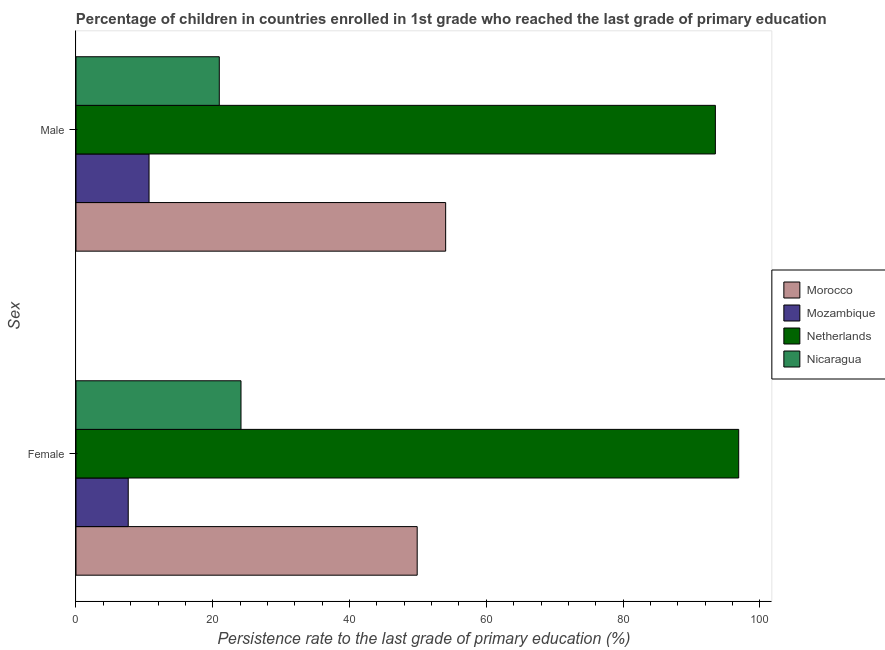How many different coloured bars are there?
Make the answer very short. 4. How many groups of bars are there?
Provide a succinct answer. 2. Are the number of bars on each tick of the Y-axis equal?
Provide a short and direct response. Yes. How many bars are there on the 2nd tick from the bottom?
Give a very brief answer. 4. What is the label of the 1st group of bars from the top?
Provide a succinct answer. Male. What is the persistence rate of female students in Mozambique?
Keep it short and to the point. 7.64. Across all countries, what is the maximum persistence rate of female students?
Give a very brief answer. 96.9. Across all countries, what is the minimum persistence rate of female students?
Keep it short and to the point. 7.64. In which country was the persistence rate of male students minimum?
Keep it short and to the point. Mozambique. What is the total persistence rate of female students in the graph?
Offer a very short reply. 178.56. What is the difference between the persistence rate of male students in Nicaragua and that in Morocco?
Your answer should be compact. -33.1. What is the difference between the persistence rate of male students in Mozambique and the persistence rate of female students in Netherlands?
Make the answer very short. -86.22. What is the average persistence rate of female students per country?
Offer a terse response. 44.64. What is the difference between the persistence rate of female students and persistence rate of male students in Morocco?
Offer a very short reply. -4.16. In how many countries, is the persistence rate of female students greater than 36 %?
Give a very brief answer. 2. What is the ratio of the persistence rate of female students in Netherlands to that in Morocco?
Your response must be concise. 1.94. In how many countries, is the persistence rate of female students greater than the average persistence rate of female students taken over all countries?
Keep it short and to the point. 2. What does the 1st bar from the top in Female represents?
Your answer should be very brief. Nicaragua. What does the 4th bar from the bottom in Female represents?
Provide a succinct answer. Nicaragua. How many bars are there?
Your answer should be compact. 8. Are the values on the major ticks of X-axis written in scientific E-notation?
Ensure brevity in your answer.  No. Does the graph contain any zero values?
Give a very brief answer. No. How are the legend labels stacked?
Offer a very short reply. Vertical. What is the title of the graph?
Offer a terse response. Percentage of children in countries enrolled in 1st grade who reached the last grade of primary education. What is the label or title of the X-axis?
Your response must be concise. Persistence rate to the last grade of primary education (%). What is the label or title of the Y-axis?
Provide a succinct answer. Sex. What is the Persistence rate to the last grade of primary education (%) of Morocco in Female?
Your response must be concise. 49.89. What is the Persistence rate to the last grade of primary education (%) in Mozambique in Female?
Keep it short and to the point. 7.64. What is the Persistence rate to the last grade of primary education (%) of Netherlands in Female?
Your answer should be compact. 96.9. What is the Persistence rate to the last grade of primary education (%) of Nicaragua in Female?
Your answer should be compact. 24.13. What is the Persistence rate to the last grade of primary education (%) of Morocco in Male?
Offer a very short reply. 54.05. What is the Persistence rate to the last grade of primary education (%) of Mozambique in Male?
Ensure brevity in your answer.  10.68. What is the Persistence rate to the last grade of primary education (%) in Netherlands in Male?
Provide a short and direct response. 93.49. What is the Persistence rate to the last grade of primary education (%) of Nicaragua in Male?
Keep it short and to the point. 20.95. Across all Sex, what is the maximum Persistence rate to the last grade of primary education (%) in Morocco?
Give a very brief answer. 54.05. Across all Sex, what is the maximum Persistence rate to the last grade of primary education (%) of Mozambique?
Make the answer very short. 10.68. Across all Sex, what is the maximum Persistence rate to the last grade of primary education (%) of Netherlands?
Give a very brief answer. 96.9. Across all Sex, what is the maximum Persistence rate to the last grade of primary education (%) in Nicaragua?
Provide a succinct answer. 24.13. Across all Sex, what is the minimum Persistence rate to the last grade of primary education (%) in Morocco?
Offer a terse response. 49.89. Across all Sex, what is the minimum Persistence rate to the last grade of primary education (%) in Mozambique?
Offer a very short reply. 7.64. Across all Sex, what is the minimum Persistence rate to the last grade of primary education (%) of Netherlands?
Offer a very short reply. 93.49. Across all Sex, what is the minimum Persistence rate to the last grade of primary education (%) of Nicaragua?
Offer a terse response. 20.95. What is the total Persistence rate to the last grade of primary education (%) of Morocco in the graph?
Give a very brief answer. 103.94. What is the total Persistence rate to the last grade of primary education (%) in Mozambique in the graph?
Give a very brief answer. 18.32. What is the total Persistence rate to the last grade of primary education (%) of Netherlands in the graph?
Give a very brief answer. 190.4. What is the total Persistence rate to the last grade of primary education (%) in Nicaragua in the graph?
Your response must be concise. 45.08. What is the difference between the Persistence rate to the last grade of primary education (%) in Morocco in Female and that in Male?
Your answer should be very brief. -4.16. What is the difference between the Persistence rate to the last grade of primary education (%) of Mozambique in Female and that in Male?
Your answer should be very brief. -3.04. What is the difference between the Persistence rate to the last grade of primary education (%) of Netherlands in Female and that in Male?
Your response must be concise. 3.41. What is the difference between the Persistence rate to the last grade of primary education (%) of Nicaragua in Female and that in Male?
Keep it short and to the point. 3.17. What is the difference between the Persistence rate to the last grade of primary education (%) of Morocco in Female and the Persistence rate to the last grade of primary education (%) of Mozambique in Male?
Provide a short and direct response. 39.21. What is the difference between the Persistence rate to the last grade of primary education (%) in Morocco in Female and the Persistence rate to the last grade of primary education (%) in Netherlands in Male?
Your answer should be compact. -43.6. What is the difference between the Persistence rate to the last grade of primary education (%) in Morocco in Female and the Persistence rate to the last grade of primary education (%) in Nicaragua in Male?
Offer a very short reply. 28.94. What is the difference between the Persistence rate to the last grade of primary education (%) of Mozambique in Female and the Persistence rate to the last grade of primary education (%) of Netherlands in Male?
Offer a terse response. -85.85. What is the difference between the Persistence rate to the last grade of primary education (%) in Mozambique in Female and the Persistence rate to the last grade of primary education (%) in Nicaragua in Male?
Offer a very short reply. -13.32. What is the difference between the Persistence rate to the last grade of primary education (%) in Netherlands in Female and the Persistence rate to the last grade of primary education (%) in Nicaragua in Male?
Provide a short and direct response. 75.95. What is the average Persistence rate to the last grade of primary education (%) in Morocco per Sex?
Provide a short and direct response. 51.97. What is the average Persistence rate to the last grade of primary education (%) of Mozambique per Sex?
Offer a very short reply. 9.16. What is the average Persistence rate to the last grade of primary education (%) in Netherlands per Sex?
Your answer should be very brief. 95.2. What is the average Persistence rate to the last grade of primary education (%) in Nicaragua per Sex?
Provide a succinct answer. 22.54. What is the difference between the Persistence rate to the last grade of primary education (%) of Morocco and Persistence rate to the last grade of primary education (%) of Mozambique in Female?
Your answer should be compact. 42.25. What is the difference between the Persistence rate to the last grade of primary education (%) of Morocco and Persistence rate to the last grade of primary education (%) of Netherlands in Female?
Make the answer very short. -47.01. What is the difference between the Persistence rate to the last grade of primary education (%) of Morocco and Persistence rate to the last grade of primary education (%) of Nicaragua in Female?
Provide a short and direct response. 25.76. What is the difference between the Persistence rate to the last grade of primary education (%) in Mozambique and Persistence rate to the last grade of primary education (%) in Netherlands in Female?
Ensure brevity in your answer.  -89.26. What is the difference between the Persistence rate to the last grade of primary education (%) in Mozambique and Persistence rate to the last grade of primary education (%) in Nicaragua in Female?
Your answer should be very brief. -16.49. What is the difference between the Persistence rate to the last grade of primary education (%) of Netherlands and Persistence rate to the last grade of primary education (%) of Nicaragua in Female?
Make the answer very short. 72.77. What is the difference between the Persistence rate to the last grade of primary education (%) of Morocco and Persistence rate to the last grade of primary education (%) of Mozambique in Male?
Provide a succinct answer. 43.37. What is the difference between the Persistence rate to the last grade of primary education (%) of Morocco and Persistence rate to the last grade of primary education (%) of Netherlands in Male?
Make the answer very short. -39.44. What is the difference between the Persistence rate to the last grade of primary education (%) of Morocco and Persistence rate to the last grade of primary education (%) of Nicaragua in Male?
Keep it short and to the point. 33.1. What is the difference between the Persistence rate to the last grade of primary education (%) of Mozambique and Persistence rate to the last grade of primary education (%) of Netherlands in Male?
Give a very brief answer. -82.81. What is the difference between the Persistence rate to the last grade of primary education (%) of Mozambique and Persistence rate to the last grade of primary education (%) of Nicaragua in Male?
Provide a short and direct response. -10.27. What is the difference between the Persistence rate to the last grade of primary education (%) of Netherlands and Persistence rate to the last grade of primary education (%) of Nicaragua in Male?
Your answer should be compact. 72.54. What is the ratio of the Persistence rate to the last grade of primary education (%) of Morocco in Female to that in Male?
Your answer should be very brief. 0.92. What is the ratio of the Persistence rate to the last grade of primary education (%) in Mozambique in Female to that in Male?
Offer a very short reply. 0.72. What is the ratio of the Persistence rate to the last grade of primary education (%) in Netherlands in Female to that in Male?
Offer a very short reply. 1.04. What is the ratio of the Persistence rate to the last grade of primary education (%) in Nicaragua in Female to that in Male?
Give a very brief answer. 1.15. What is the difference between the highest and the second highest Persistence rate to the last grade of primary education (%) of Morocco?
Ensure brevity in your answer.  4.16. What is the difference between the highest and the second highest Persistence rate to the last grade of primary education (%) of Mozambique?
Provide a short and direct response. 3.04. What is the difference between the highest and the second highest Persistence rate to the last grade of primary education (%) in Netherlands?
Make the answer very short. 3.41. What is the difference between the highest and the second highest Persistence rate to the last grade of primary education (%) in Nicaragua?
Your answer should be very brief. 3.17. What is the difference between the highest and the lowest Persistence rate to the last grade of primary education (%) in Morocco?
Offer a very short reply. 4.16. What is the difference between the highest and the lowest Persistence rate to the last grade of primary education (%) in Mozambique?
Make the answer very short. 3.04. What is the difference between the highest and the lowest Persistence rate to the last grade of primary education (%) in Netherlands?
Offer a terse response. 3.41. What is the difference between the highest and the lowest Persistence rate to the last grade of primary education (%) of Nicaragua?
Ensure brevity in your answer.  3.17. 